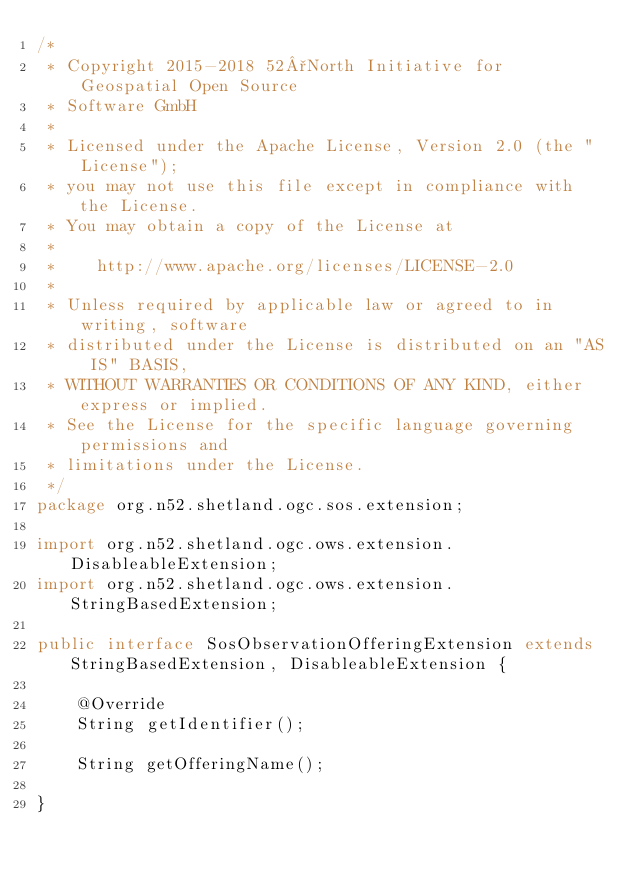Convert code to text. <code><loc_0><loc_0><loc_500><loc_500><_Java_>/*
 * Copyright 2015-2018 52°North Initiative for Geospatial Open Source
 * Software GmbH
 *
 * Licensed under the Apache License, Version 2.0 (the "License");
 * you may not use this file except in compliance with the License.
 * You may obtain a copy of the License at
 *
 *    http://www.apache.org/licenses/LICENSE-2.0
 *
 * Unless required by applicable law or agreed to in writing, software
 * distributed under the License is distributed on an "AS IS" BASIS,
 * WITHOUT WARRANTIES OR CONDITIONS OF ANY KIND, either express or implied.
 * See the License for the specific language governing permissions and
 * limitations under the License.
 */
package org.n52.shetland.ogc.sos.extension;

import org.n52.shetland.ogc.ows.extension.DisableableExtension;
import org.n52.shetland.ogc.ows.extension.StringBasedExtension;

public interface SosObservationOfferingExtension extends StringBasedExtension, DisableableExtension {

    @Override
    String getIdentifier();

    String getOfferingName();

}
</code> 